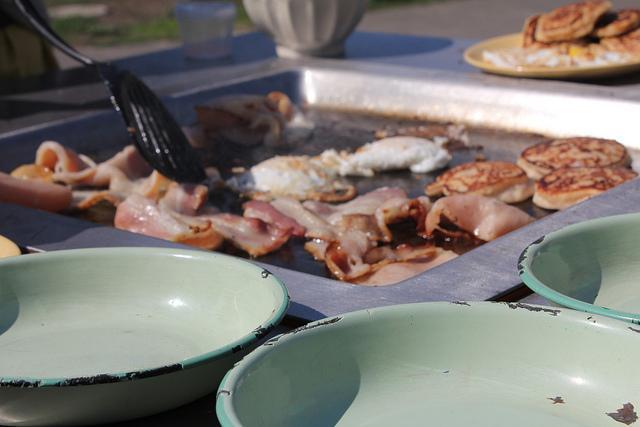How many bowls are there?
Give a very brief answer. 3. How many cups can be seen?
Give a very brief answer. 2. 